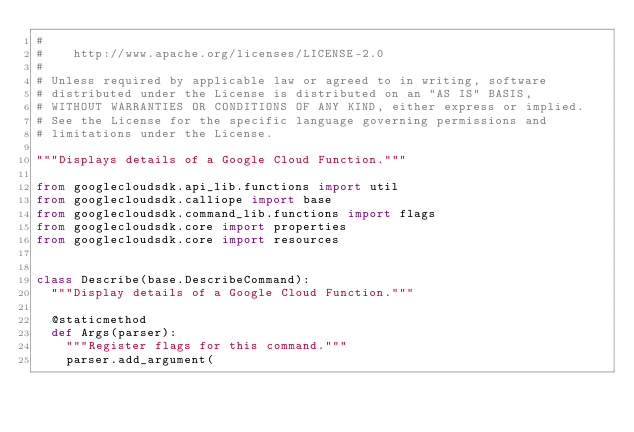Convert code to text. <code><loc_0><loc_0><loc_500><loc_500><_Python_>#
#    http://www.apache.org/licenses/LICENSE-2.0
#
# Unless required by applicable law or agreed to in writing, software
# distributed under the License is distributed on an "AS IS" BASIS,
# WITHOUT WARRANTIES OR CONDITIONS OF ANY KIND, either express or implied.
# See the License for the specific language governing permissions and
# limitations under the License.

"""Displays details of a Google Cloud Function."""

from googlecloudsdk.api_lib.functions import util
from googlecloudsdk.calliope import base
from googlecloudsdk.command_lib.functions import flags
from googlecloudsdk.core import properties
from googlecloudsdk.core import resources


class Describe(base.DescribeCommand):
  """Display details of a Google Cloud Function."""

  @staticmethod
  def Args(parser):
    """Register flags for this command."""
    parser.add_argument(</code> 